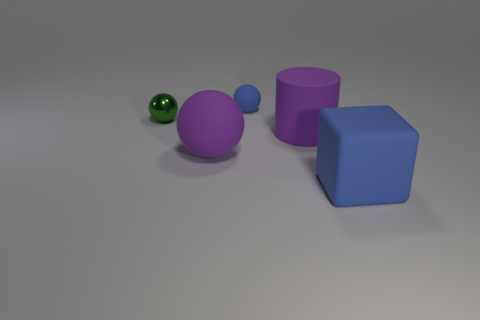Is the size of the matte object that is left of the small blue thing the same as the blue object to the right of the blue ball?
Give a very brief answer. Yes. The ball left of the large rubber ball to the left of the small blue thing is made of what material?
Your answer should be very brief. Metal. Are there fewer big purple matte cylinders that are behind the tiny blue ball than blue cubes that are in front of the large block?
Give a very brief answer. No. Are there any other things that have the same shape as the large blue object?
Offer a very short reply. No. There is a ball that is to the left of the large matte ball; what is it made of?
Your answer should be compact. Metal. Are there any small rubber things behind the big blue matte block?
Your answer should be very brief. Yes. What is the shape of the tiny matte thing?
Offer a terse response. Sphere. How many things are either matte spheres behind the large purple sphere or big metal objects?
Your response must be concise. 1. How many other things are there of the same color as the metal ball?
Make the answer very short. 0. There is a big rubber sphere; is its color the same as the big thing behind the large purple ball?
Make the answer very short. Yes. 